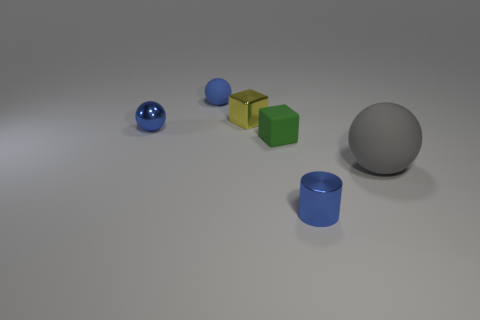Subtract all small rubber spheres. How many spheres are left? 2 Add 4 green objects. How many objects exist? 10 Subtract all cylinders. How many objects are left? 5 Subtract all green balls. Subtract all cyan cubes. How many balls are left? 3 Subtract 0 green cylinders. How many objects are left? 6 Subtract all small metallic blocks. Subtract all blue balls. How many objects are left? 3 Add 5 yellow things. How many yellow things are left? 6 Add 1 small blue balls. How many small blue balls exist? 3 